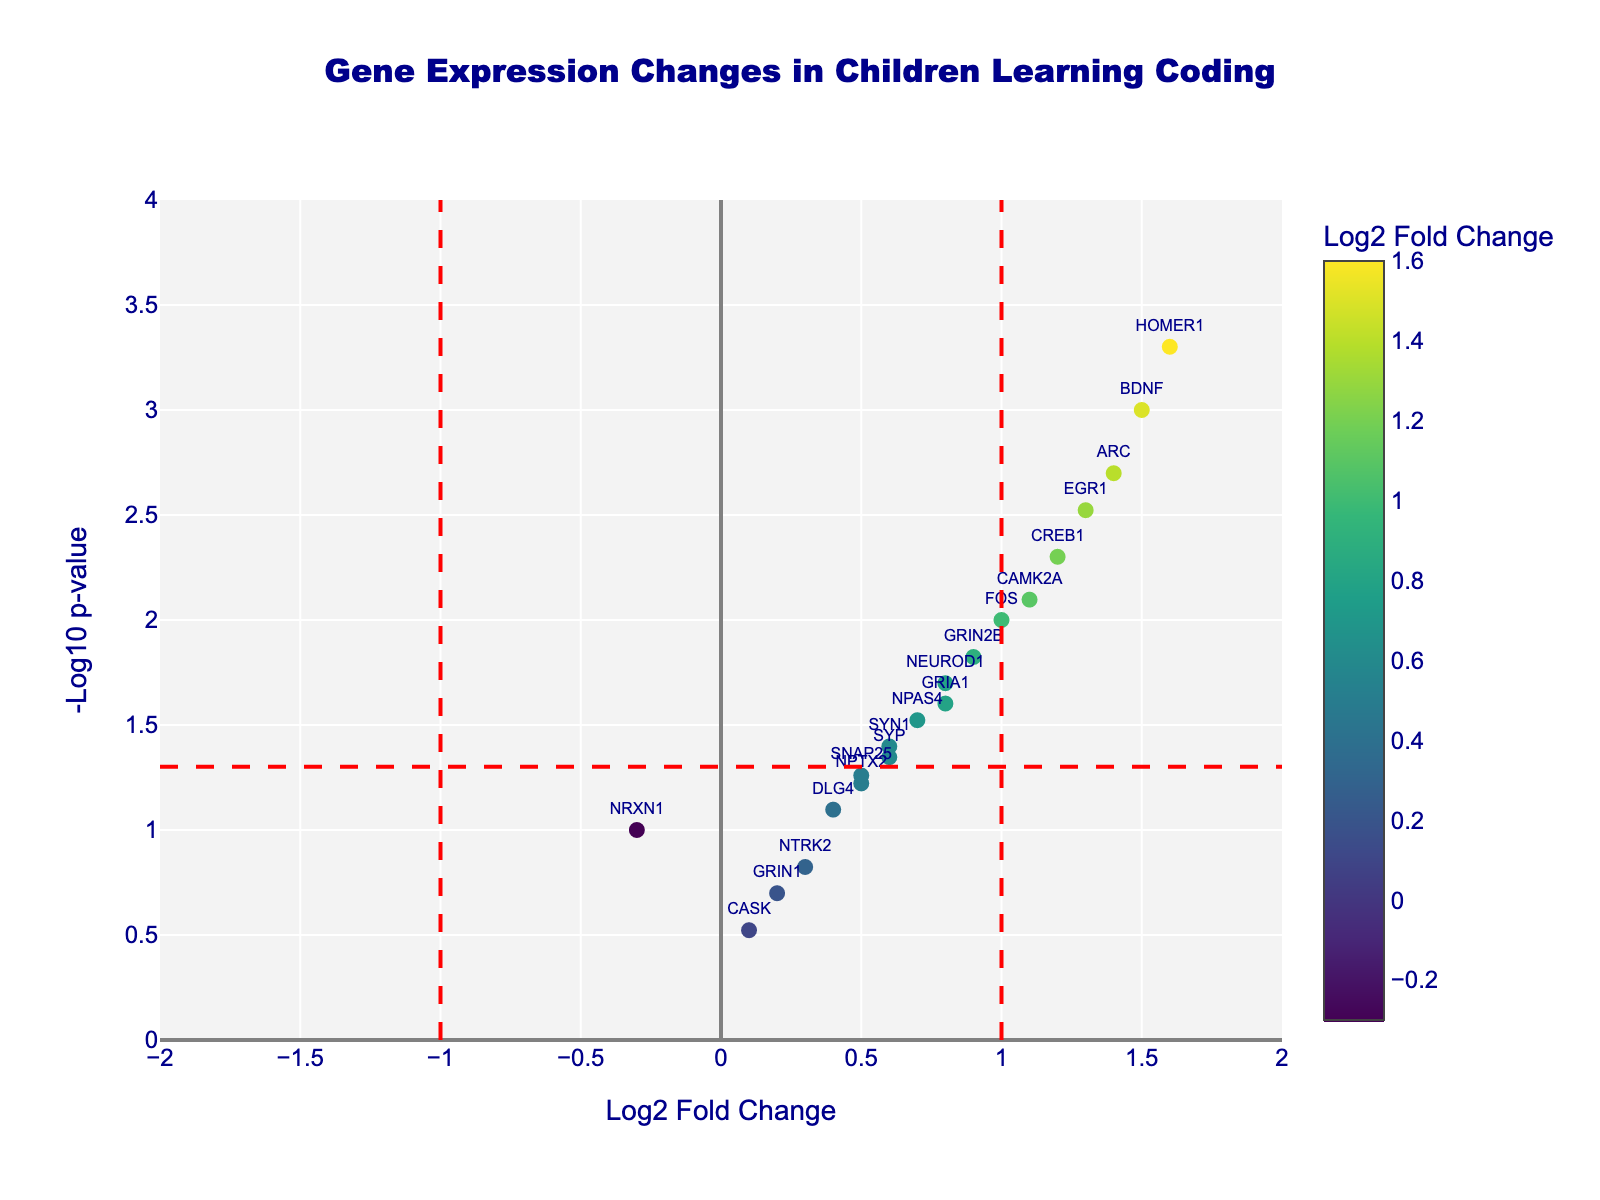How many genes are labeled in the volcano plot? Count the number of gene labels displayed on the plot.
Answer: 20 Which gene has the highest log2 fold change in the plot? Look for the gene on the x-axis with the highest value of log2 fold change. The gene "HOMER1" has the highest log2 fold change with a value of 1.6.
Answer: HOMER1 Which gene has the lowest p-value in the plot? Check the y-axis for the highest -log10(p) value because a lower p-value results in a higher -log10(p) value. "HOMER1" has the highest -log10(p) which means it has the lowest p-value.
Answer: HOMER1 Are there any genes with a negative log2 fold change? If so, name one. Look at the x-axis for genes positioned to the left of zero. "NRXN1" is an example.
Answer: NRXN1 What is the p-value threshold used in the plot? Identify the horizontal line drawn in the plot, which indicates the p-value threshold. The line is at -log10(0.05), which corresponds to p = 0.05.
Answer: 0.05 How many genes have a p-value less than 0.05? Count the number of points above the horizontal line at -log10(0.05). There are 11 genes above this line.
Answer: 11 Which genes have a log2 fold change less than 0 but are not significant (p-value > 0.05)? Look at the left side of the zero line on the x-axis and identify points below the horizontal threshold line at -log10(0.05). "NRXN1" and "CASK" fall in this category.
Answer: NRXN1, CASK What is the range of log2 fold changes in the plot? Identify the minimum and maximum values on the x-axis. The range goes from -0.3 (NRXN1) to 1.6 (HOMER1).
Answer: -0.3 to 1.6 What is the range of -log10(p) values in this plot? Identify the minimum and maximum values on the y-axis. The range is from 0 to 3.30.
Answer: 0 to 3.30 